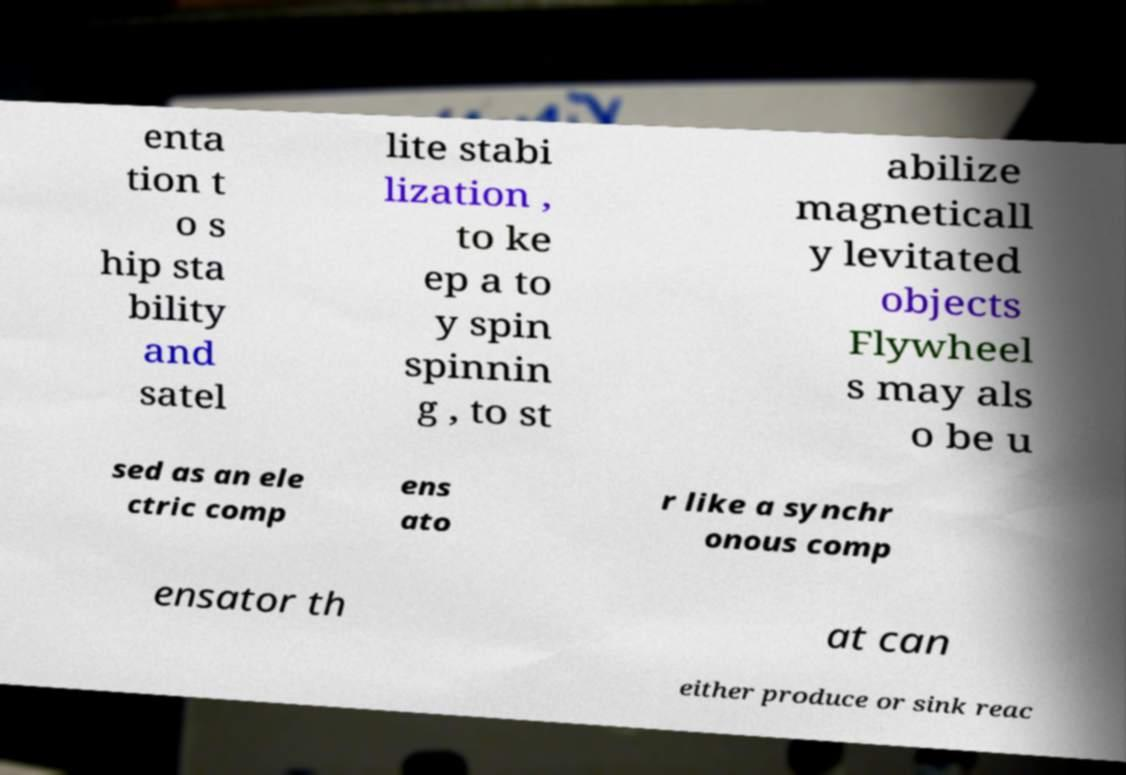What messages or text are displayed in this image? I need them in a readable, typed format. enta tion t o s hip sta bility and satel lite stabi lization , to ke ep a to y spin spinnin g , to st abilize magneticall y levitated objects Flywheel s may als o be u sed as an ele ctric comp ens ato r like a synchr onous comp ensator th at can either produce or sink reac 